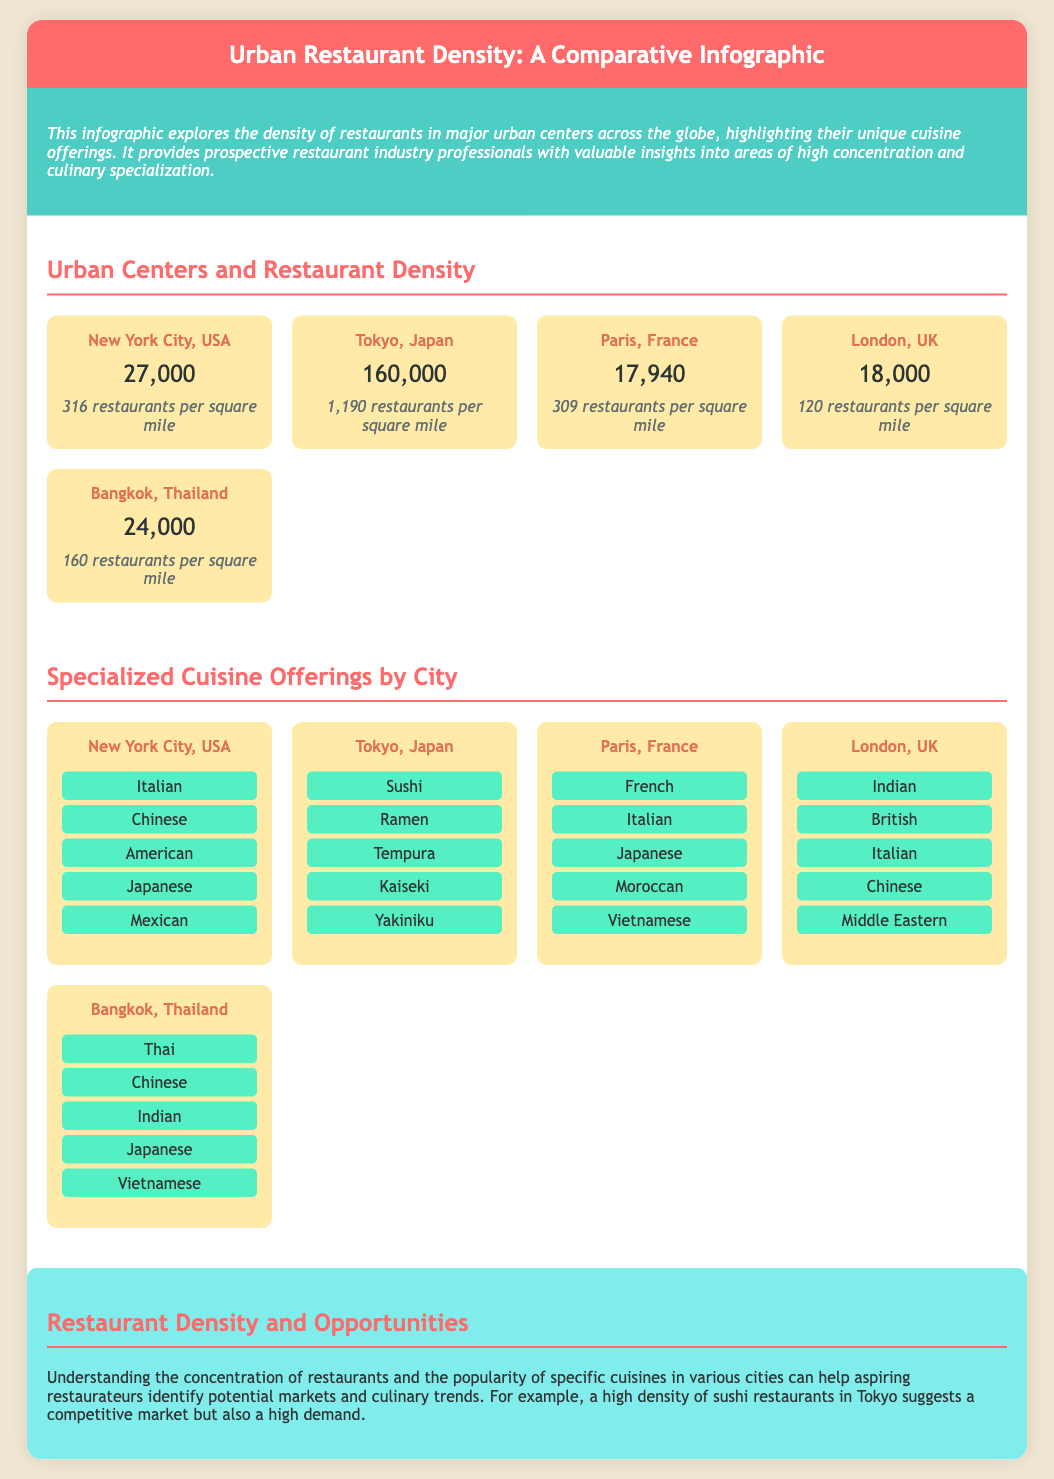What is the restaurant count in Tokyo? The document provides the specific restaurant count for Tokyo, which is stated clearly.
Answer: 160,000 Which city has the highest restaurant density? The infographic indicates restaurant density per square mile for each city, highlighting the one with the highest density.
Answer: Tokyo How many specialized cuisines are listed for Paris? The document details the specialized cuisine offerings for various cities, allowing for a count of those offered in Paris.
Answer: 5 What is the restaurant density of New York City? The infographic specifies the restaurant density for New York City per square mile, providing a clear answer.
Answer: 316 restaurants per square mile Which cuisine is popular in London? The document lists the diverse cuisines available in London, allowing for identification of a popular cuisine.
Answer: Indian What city offers Kaiseki cuisine? The infographic mentions specific specialized cuisines for each city, helping identify where Kaiseki is offered.
Answer: Tokyo How many restaurants per square mile are in London? The document states the density of restaurants for London, which can be directly referenced.
Answer: 120 restaurants per square mile What is the total number of restaurants listed for Bangkok? The infographic provides a precise restaurant count for Bangkok, which can be found in the content.
Answer: 24,000 Which city has the lowest number of restaurants? The document compares restaurant counts across cities, allowing for the identification of the city with the least number.
Answer: London 